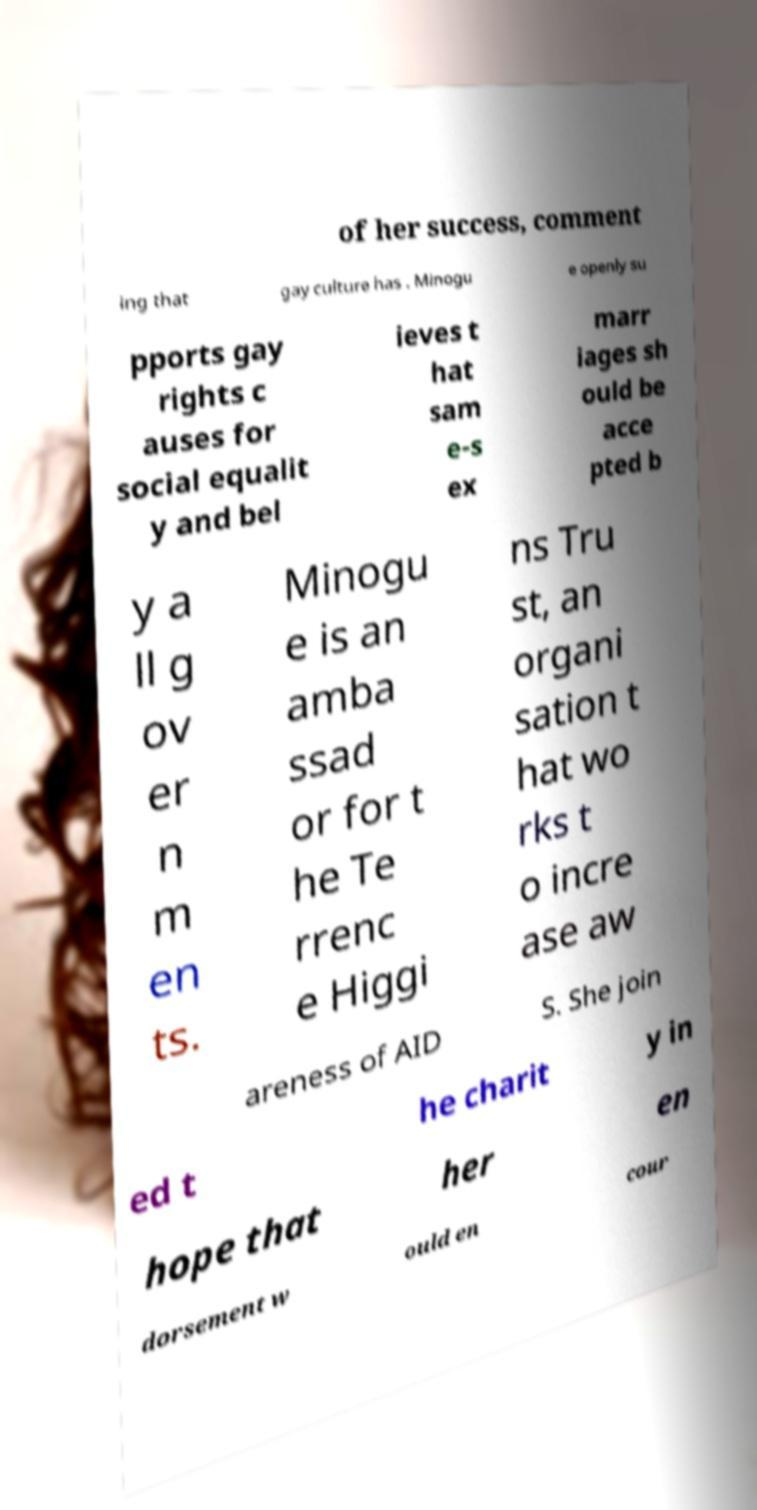I need the written content from this picture converted into text. Can you do that? of her success, comment ing that gay culture has . Minogu e openly su pports gay rights c auses for social equalit y and bel ieves t hat sam e-s ex marr iages sh ould be acce pted b y a ll g ov er n m en ts. Minogu e is an amba ssad or for t he Te rrenc e Higgi ns Tru st, an organi sation t hat wo rks t o incre ase aw areness of AID S. She join ed t he charit y in hope that her en dorsement w ould en cour 